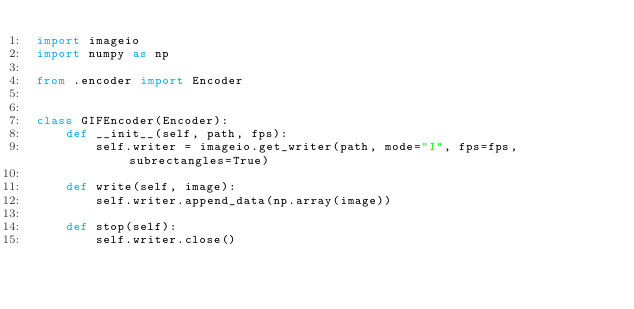Convert code to text. <code><loc_0><loc_0><loc_500><loc_500><_Python_>import imageio
import numpy as np

from .encoder import Encoder


class GIFEncoder(Encoder):
    def __init__(self, path, fps):
        self.writer = imageio.get_writer(path, mode="I", fps=fps, subrectangles=True)

    def write(self, image):
        self.writer.append_data(np.array(image))

    def stop(self):
        self.writer.close()
</code> 